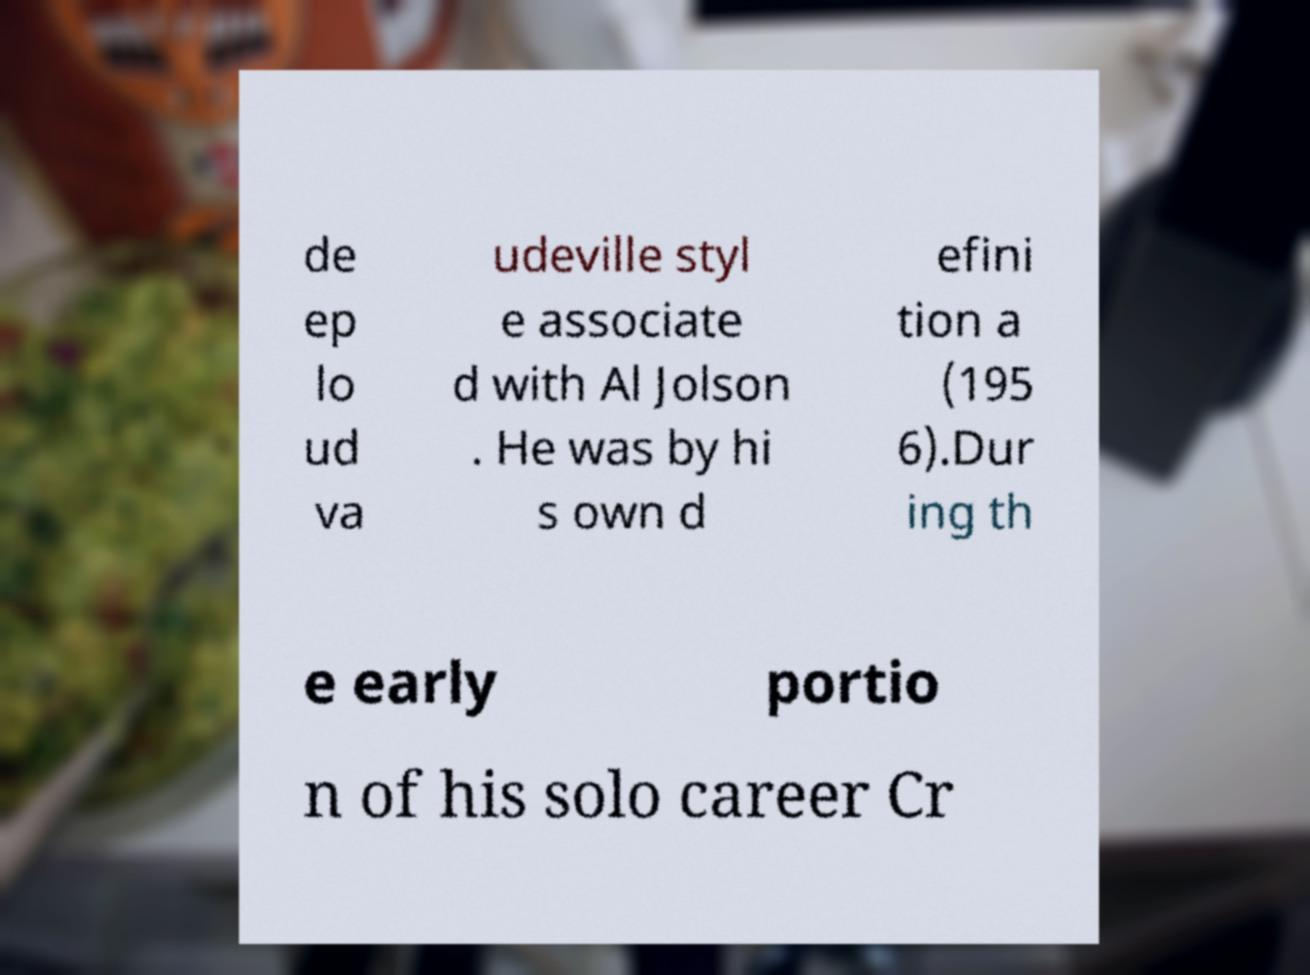Please identify and transcribe the text found in this image. de ep lo ud va udeville styl e associate d with Al Jolson . He was by hi s own d efini tion a (195 6).Dur ing th e early portio n of his solo career Cr 